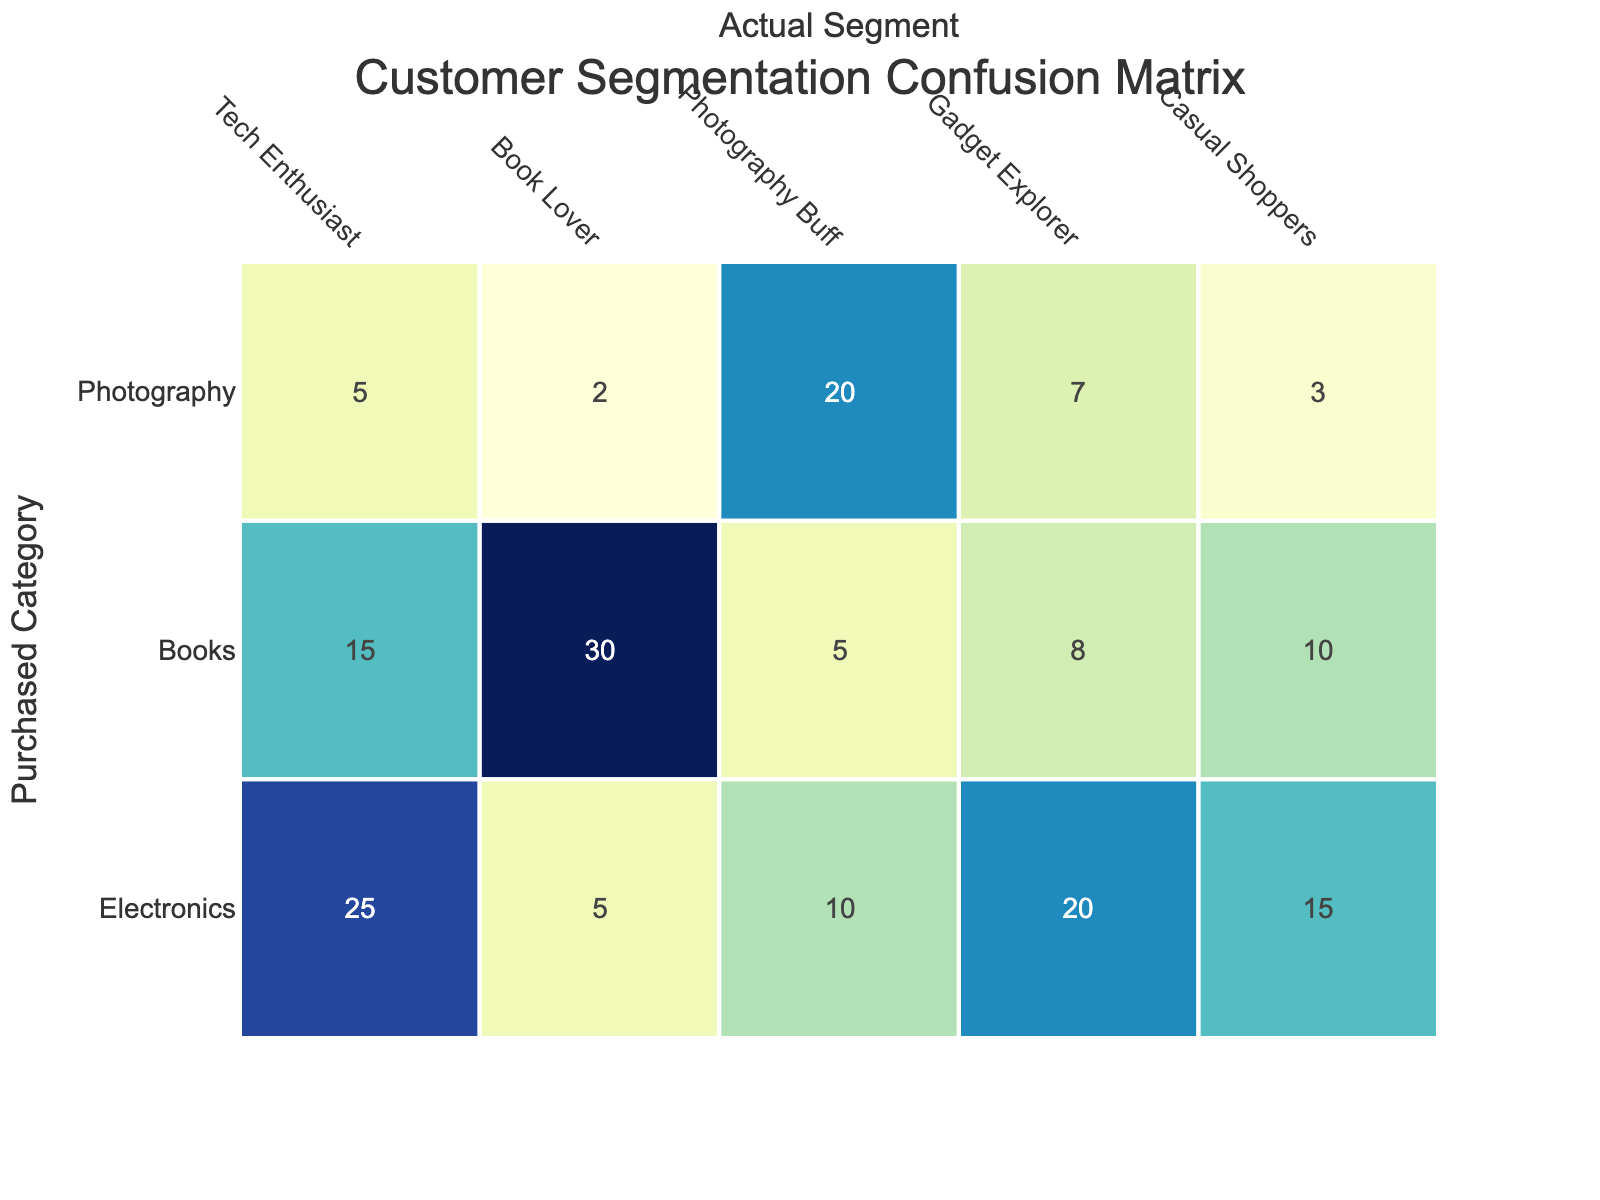What is the total number of Tech Enthusiasts that have purchased Electronics? Referring to the table, the number of Tech Enthusiasts who purchased Electronics is directly listed under the "Purchased Electronics" column for the "Tech Enthusiast" row. That number is 25.
Answer: 25 How many customers in total purchased Books? To find the total number of customers who purchased Books, we need to sum the values in the "Purchased Books" column across all segments: 15 (Tech Enthusiast) + 30 (Book Lover) + 5 (Photography Buff) + 8 (Gadget Explorer) + 10 (Casual Shoppers) = 68.
Answer: 68 Is there a segment that purchased more Photography Gear than Electronics? Analyzing the segments, we check each segment's values for Photography Gear and Electronics. The "Photography Buff" has 20 purchases in Photography Gear and 10 in Electronics, which verifies the condition. Thus, yes, there is at least one segment.
Answer: Yes What is the average number of Electronics purchased across all segments? To find the average, first, sum the Electronics purchases: 25 + 5 + 10 + 20 + 15 = 75. Then, divide by the number of segments, which is 5. This gives an average of 75 / 5 = 15.
Answer: 15 How many customers are there in the Gadget Explorer segment who bought Books? In the table, the number of Gadget Explorers who purchased Books is provided directly in the "Purchased Books" column for the "Gadget Explorer" row, which is 8.
Answer: 8 Which segment has the highest total number of customers? To determine this, we compare the total customers for each segment: Tech Enthusiast (45), Book Lover (37), Photography Buff (35), Gadget Explorer (35), and Casual Shoppers (28). The Tech Enthusiast segment has the highest total at 45.
Answer: Tech Enthusiast What is the difference between the number of purchased Electronics by Book Lovers and Casual Shoppers? From the table, Book Lovers purchased 5 Electronics and Casual Shoppers purchased 15 Electronics. The difference is 15 - 5 = 10.
Answer: 10 Which segment purchased the least number of Photography Gear? Checking the values in the "Purchased Photography Gear" column, we see the counts: Tech Enthusiast (5), Book Lover (2), Photography Buff (20), Gadget Explorer (7), and Casual Shoppers (3). The Book Lover has the lowest value with 2.
Answer: Book Lover If we consider all segments, how many more customers purchased Books than Photography Gear? We first sum the total customers who purchased Books (68) and Photography Gear (45) across all segments. The difference is 68 (Books) - 45 (Photography Gear) = 23, meaning more customers purchased Books.
Answer: 23 